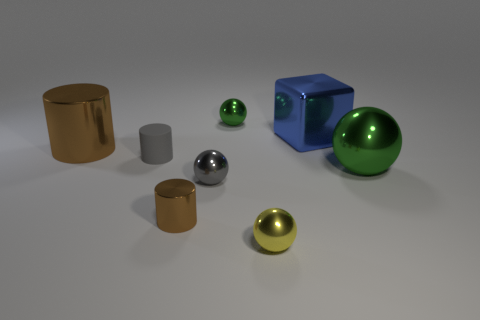Is there any other thing that has the same material as the small gray cylinder?
Offer a terse response. No. What number of cylinders have the same color as the large metal ball?
Ensure brevity in your answer.  0. What number of things are small gray rubber cylinders or large brown spheres?
Your response must be concise. 1. There is a matte thing that is the same size as the yellow metal object; what shape is it?
Offer a very short reply. Cylinder. How many small things are both left of the gray sphere and in front of the gray metallic ball?
Offer a very short reply. 1. What is the green object that is on the left side of the large green metal ball made of?
Your answer should be compact. Metal. What size is the yellow ball that is the same material as the blue object?
Provide a succinct answer. Small. Do the metallic sphere behind the big green metallic ball and the brown cylinder behind the gray matte object have the same size?
Your response must be concise. No. There is a cylinder that is the same size as the metallic block; what is it made of?
Provide a succinct answer. Metal. There is a tiny thing that is behind the large ball and in front of the big blue cube; what is its material?
Provide a succinct answer. Rubber. 